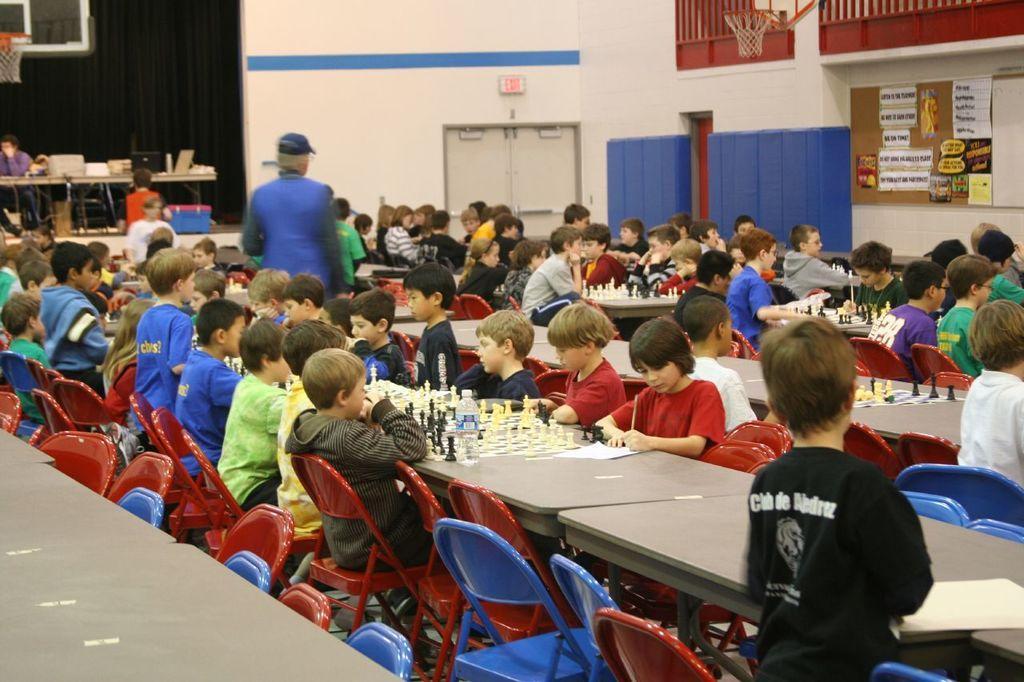In one or two sentences, can you explain what this image depicts? In this image we can see children sitting on the chairs and tables are placed in front of them. On the tables there are chess boards, chess coins, disposable bottles and papers. In the background there are sign boards, desktops, cables, doors and some parts pasted on the wall. 